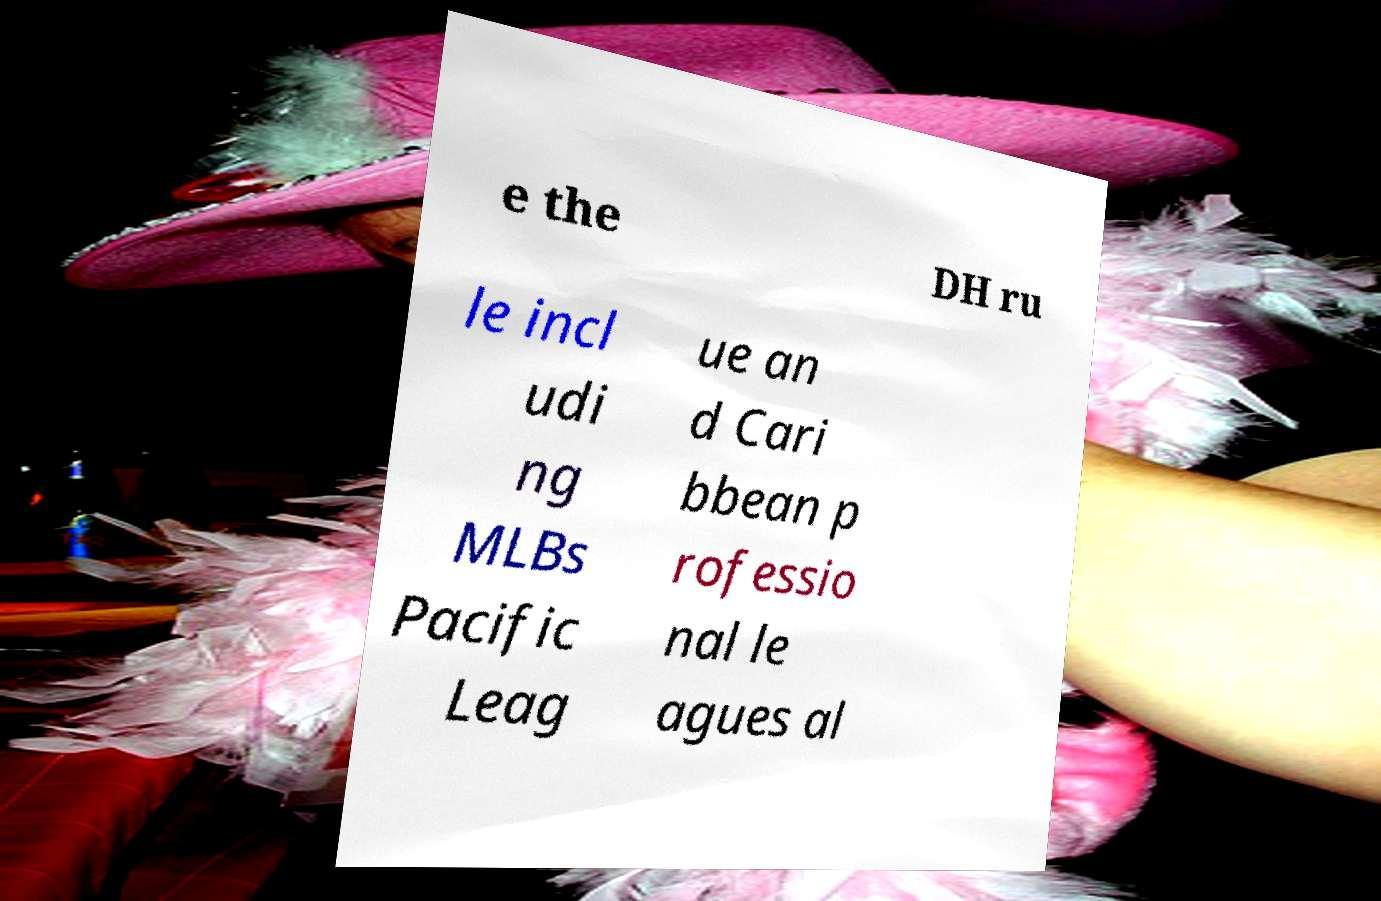Could you assist in decoding the text presented in this image and type it out clearly? e the DH ru le incl udi ng MLBs Pacific Leag ue an d Cari bbean p rofessio nal le agues al 